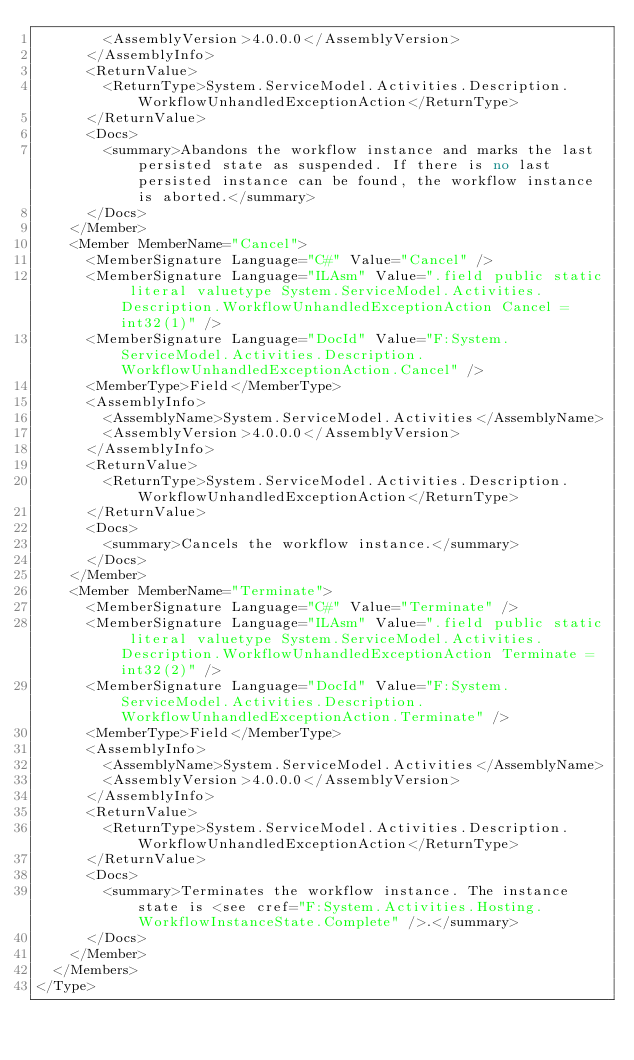Convert code to text. <code><loc_0><loc_0><loc_500><loc_500><_XML_>        <AssemblyVersion>4.0.0.0</AssemblyVersion>
      </AssemblyInfo>
      <ReturnValue>
        <ReturnType>System.ServiceModel.Activities.Description.WorkflowUnhandledExceptionAction</ReturnType>
      </ReturnValue>
      <Docs>
        <summary>Abandons the workflow instance and marks the last persisted state as suspended. If there is no last persisted instance can be found, the workflow instance is aborted.</summary>
      </Docs>
    </Member>
    <Member MemberName="Cancel">
      <MemberSignature Language="C#" Value="Cancel" />
      <MemberSignature Language="ILAsm" Value=".field public static literal valuetype System.ServiceModel.Activities.Description.WorkflowUnhandledExceptionAction Cancel = int32(1)" />
      <MemberSignature Language="DocId" Value="F:System.ServiceModel.Activities.Description.WorkflowUnhandledExceptionAction.Cancel" />
      <MemberType>Field</MemberType>
      <AssemblyInfo>
        <AssemblyName>System.ServiceModel.Activities</AssemblyName>
        <AssemblyVersion>4.0.0.0</AssemblyVersion>
      </AssemblyInfo>
      <ReturnValue>
        <ReturnType>System.ServiceModel.Activities.Description.WorkflowUnhandledExceptionAction</ReturnType>
      </ReturnValue>
      <Docs>
        <summary>Cancels the workflow instance.</summary>
      </Docs>
    </Member>
    <Member MemberName="Terminate">
      <MemberSignature Language="C#" Value="Terminate" />
      <MemberSignature Language="ILAsm" Value=".field public static literal valuetype System.ServiceModel.Activities.Description.WorkflowUnhandledExceptionAction Terminate = int32(2)" />
      <MemberSignature Language="DocId" Value="F:System.ServiceModel.Activities.Description.WorkflowUnhandledExceptionAction.Terminate" />
      <MemberType>Field</MemberType>
      <AssemblyInfo>
        <AssemblyName>System.ServiceModel.Activities</AssemblyName>
        <AssemblyVersion>4.0.0.0</AssemblyVersion>
      </AssemblyInfo>
      <ReturnValue>
        <ReturnType>System.ServiceModel.Activities.Description.WorkflowUnhandledExceptionAction</ReturnType>
      </ReturnValue>
      <Docs>
        <summary>Terminates the workflow instance. The instance state is <see cref="F:System.Activities.Hosting.WorkflowInstanceState.Complete" />.</summary>
      </Docs>
    </Member>
  </Members>
</Type>
</code> 